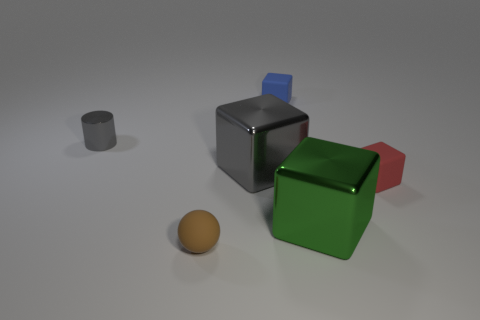Subtract all big gray shiny blocks. How many blocks are left? 3 Add 3 small red rubber things. How many objects exist? 9 Subtract all red blocks. How many blocks are left? 3 Subtract 1 cubes. How many cubes are left? 3 Subtract all cylinders. How many objects are left? 5 Subtract all brown blocks. Subtract all green spheres. How many blocks are left? 4 Subtract 0 yellow cylinders. How many objects are left? 6 Subtract all small cyan metal spheres. Subtract all large gray metallic cubes. How many objects are left? 5 Add 3 small rubber cubes. How many small rubber cubes are left? 5 Add 6 metal cubes. How many metal cubes exist? 8 